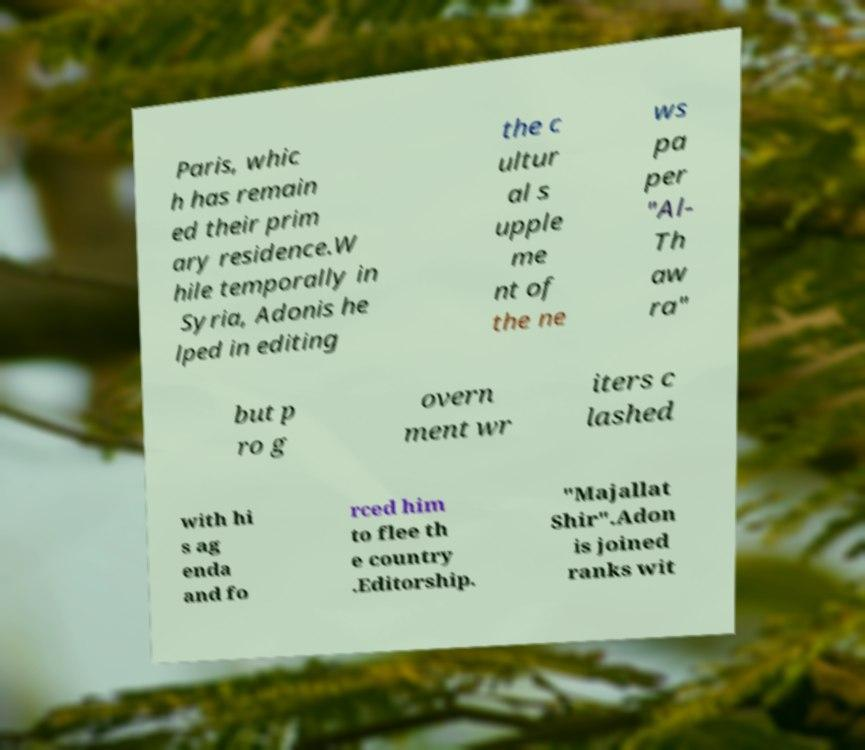Please identify and transcribe the text found in this image. Paris, whic h has remain ed their prim ary residence.W hile temporally in Syria, Adonis he lped in editing the c ultur al s upple me nt of the ne ws pa per "Al- Th aw ra" but p ro g overn ment wr iters c lashed with hi s ag enda and fo rced him to flee th e country .Editorship. "Majallat Shir".Adon is joined ranks wit 